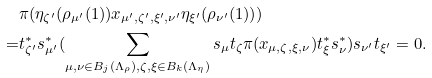<formula> <loc_0><loc_0><loc_500><loc_500>& \pi ( \eta _ { \zeta ^ { \prime } } ( \rho _ { \mu ^ { \prime } } ( 1 ) ) x _ { \mu ^ { \prime } , \zeta ^ { \prime } , \xi ^ { \prime } , \nu ^ { \prime } } \eta _ { \xi ^ { \prime } } ( \rho _ { \nu ^ { \prime } } ( 1 ) ) ) \\ = & t _ { \zeta ^ { \prime } } ^ { * } s _ { \mu ^ { \prime } } ^ { * } ( \sum _ { \mu , \nu \in B _ { j } ( \Lambda _ { \rho } ) , \zeta , \xi \in B _ { k } ( \Lambda _ { \eta } ) } s _ { \mu } t _ { \zeta } \pi ( x _ { \mu , \zeta , \xi , \nu } ) t _ { \xi } ^ { * } s _ { \nu } ^ { * } ) s _ { \nu ^ { \prime } } t _ { \xi ^ { \prime } } = 0 .</formula> 